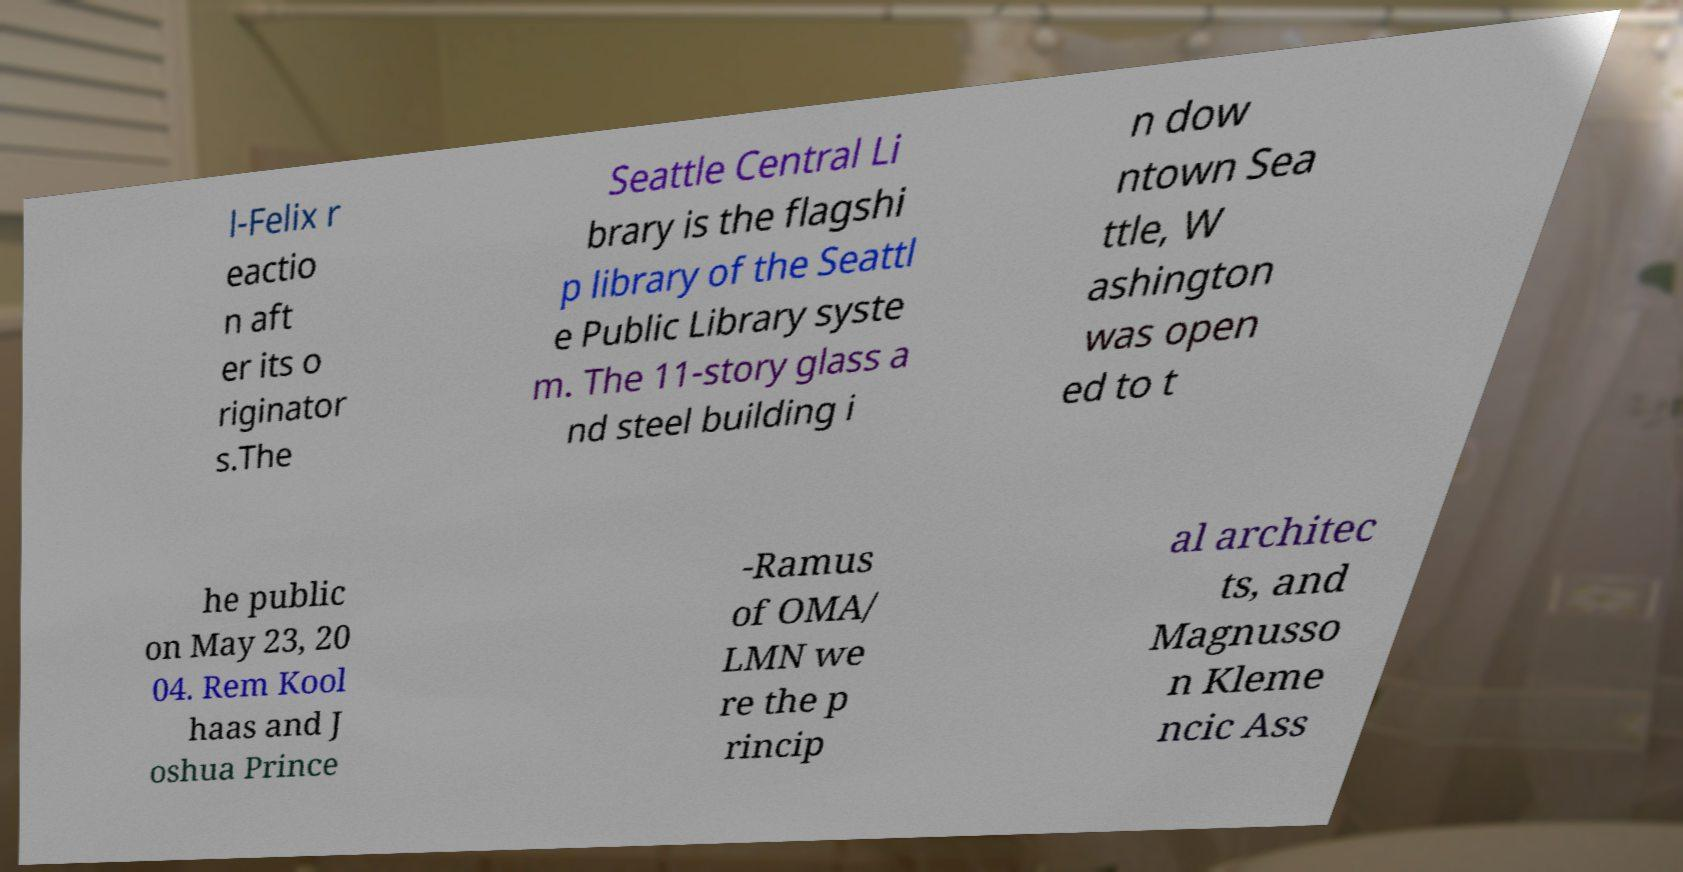There's text embedded in this image that I need extracted. Can you transcribe it verbatim? l-Felix r eactio n aft er its o riginator s.The Seattle Central Li brary is the flagshi p library of the Seattl e Public Library syste m. The 11-story glass a nd steel building i n dow ntown Sea ttle, W ashington was open ed to t he public on May 23, 20 04. Rem Kool haas and J oshua Prince -Ramus of OMA/ LMN we re the p rincip al architec ts, and Magnusso n Kleme ncic Ass 